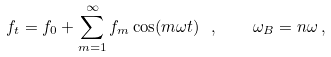<formula> <loc_0><loc_0><loc_500><loc_500>f _ { t } = f _ { 0 } + \sum _ { m = 1 } ^ { \infty } f _ { m } \cos ( m \omega t ) \ , \quad \omega _ { B } = n \omega \, ,</formula> 